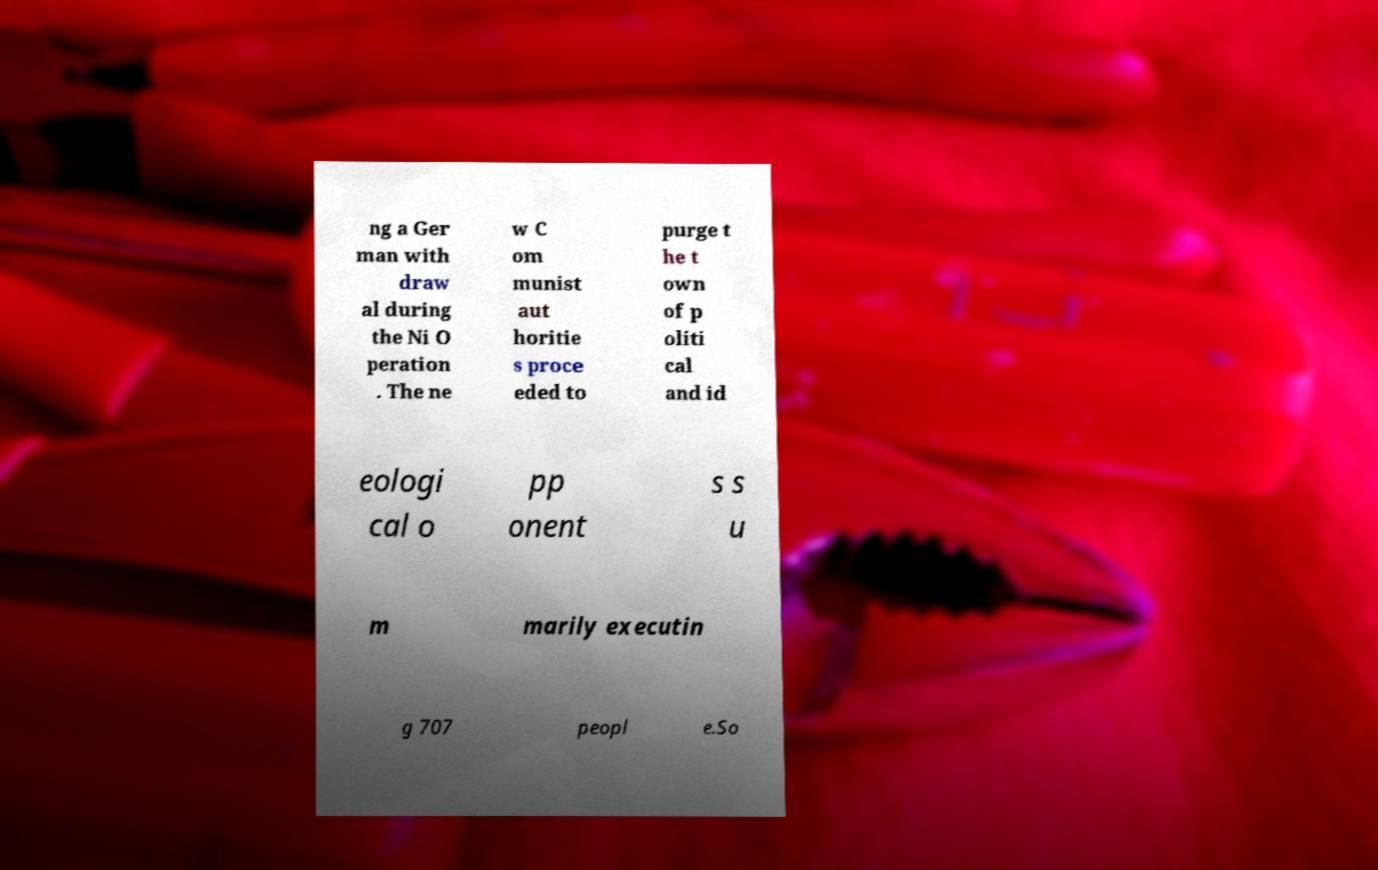Can you read and provide the text displayed in the image?This photo seems to have some interesting text. Can you extract and type it out for me? ng a Ger man with draw al during the Ni O peration . The ne w C om munist aut horitie s proce eded to purge t he t own of p oliti cal and id eologi cal o pp onent s s u m marily executin g 707 peopl e.So 